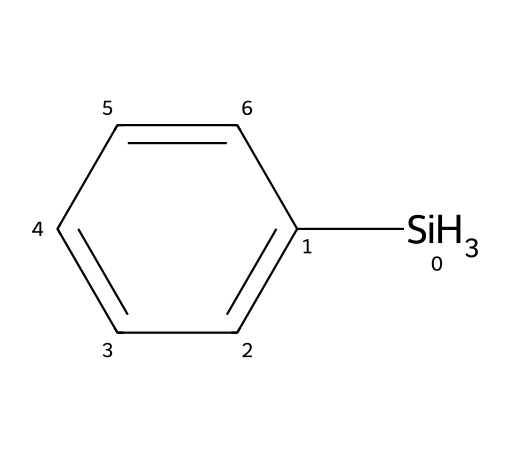What is the main functional group in phenylsilane? The structure shows a silicon atom attached to a phenyl ring, indicating that it is an organosilicon compound with a silicon functional group.
Answer: silicon How many hydrogen atoms are present in phenylsilane? Analyzing the chemical structure, there are three hydrogen atoms attached to the silicon atom and five hydrogen atoms from the phenyl ring, totaling eight hydrogen atoms.
Answer: eight What is the total number of carbon atoms in phenylsilane? The chemical structure includes a phenyl ring, which consists of six carbon atoms. Therefore, there are six carbon atoms in phenylsilane.
Answer: six How many bonds connect the carbon atoms in the phenyl ring? The phenyl ring displays a resonance structure with alternating double bonds, confirming that there are five total carbon-carbon bonds in the ring.
Answer: five What is the hybridization of the silicon atom in phenylsilane? The silicon atom is bonded to three hydrogen atoms and one carbon atom, leading to a tetrahedral geometry indicating an sp3 hybridization for silicon.
Answer: sp3 Is phenylsilane a saturated or unsaturated compound? Given that there are no multiple bonds in the phenylsilane structure and all valences are satisfied, it is classified as a saturated compound.
Answer: saturated 